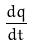Convert formula to latex. <formula><loc_0><loc_0><loc_500><loc_500>\frac { d q } { d t }</formula> 